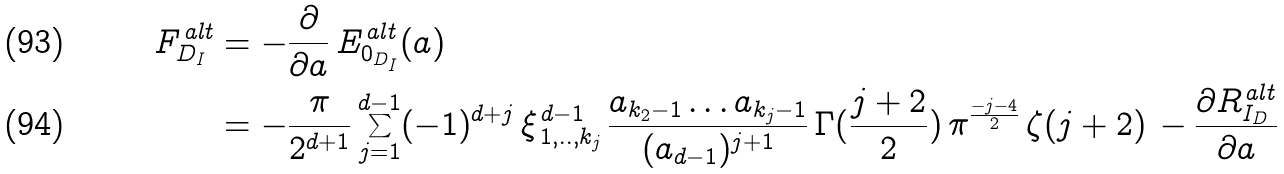<formula> <loc_0><loc_0><loc_500><loc_500>F ^ { \, a l t } _ { D _ { I } } & = - \frac { \partial } { \partial a } \, E ^ { \, a l t } _ { 0 _ { D _ { I } } } ( a ) \\ & = - \frac { \pi } { 2 ^ { d + 1 } } \sum _ { j = 1 } ^ { d - 1 } ( - 1 ) ^ { d + j } \, \xi ^ { \, d - 1 } _ { \, 1 , . . , k _ { j } } \, \frac { a _ { k _ { 2 } - 1 } \dots a _ { k _ { j } - 1 } } { ( a _ { d - 1 } ) ^ { j + 1 } } \, \Gamma ( \frac { j + 2 } { 2 } ) \, \pi ^ { \frac { - j - 4 } { 2 } } \, \zeta ( j + 2 ) \, - \frac { \partial R ^ { \, a l t } _ { I _ { D } } } { \partial a }</formula> 